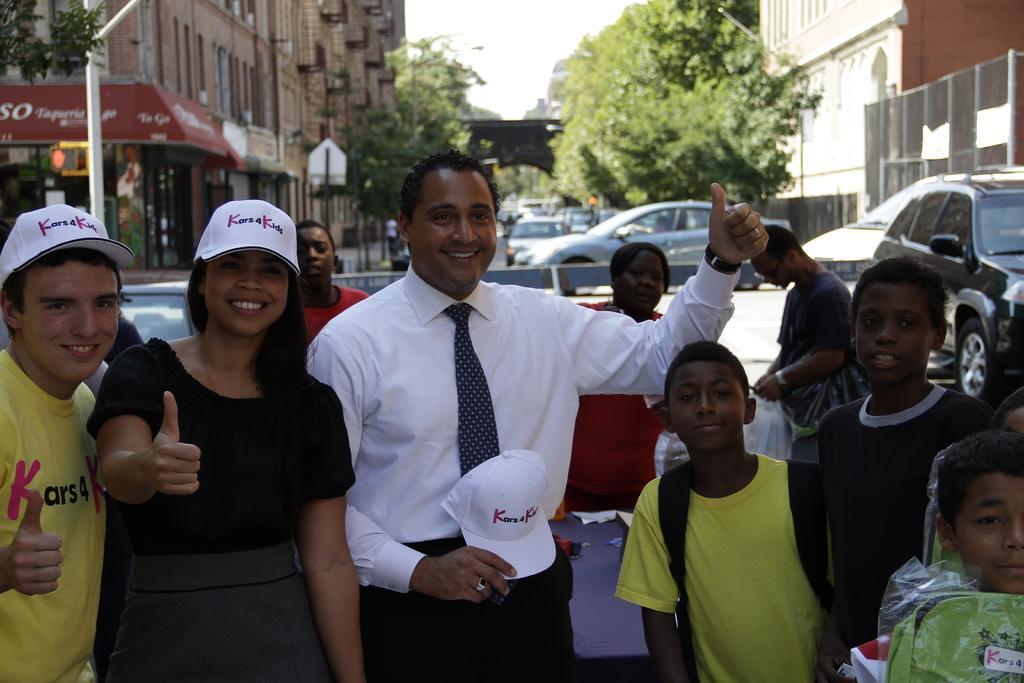Describe this image in one or two sentences. In this picture, we see many people standing on the road. The man in the middle of the picture wearing a white shirt is holding white cap in his hand and he is smiling. Beside him, the woman in a black dress who is wearing a white cap is also smiling. Behind them, we see many cars moving on the road and on either side of the road, we see trees and buildings. In the left top of the picture, we see a pole and we even see a red board with some text written on it. At the top of the picture, we see the sky and this picture is clicked outside the city. 